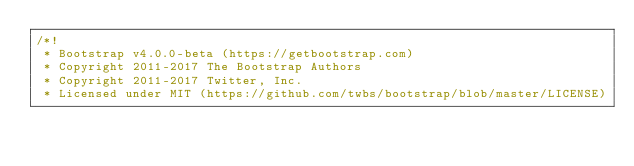<code> <loc_0><loc_0><loc_500><loc_500><_CSS_>/*!
 * Bootstrap v4.0.0-beta (https://getbootstrap.com)
 * Copyright 2011-2017 The Bootstrap Authors
 * Copyright 2011-2017 Twitter, Inc.
 * Licensed under MIT (https://github.com/twbs/bootstrap/blob/master/LICENSE)</code> 